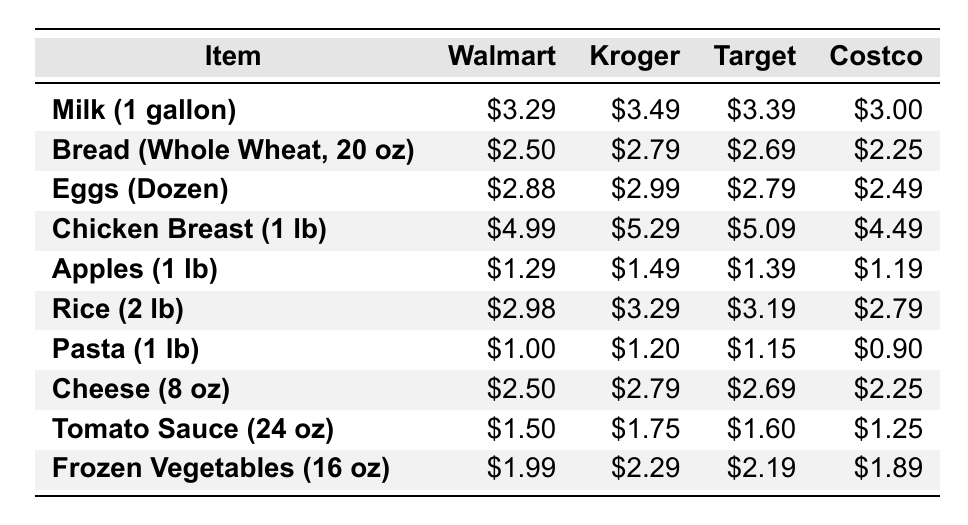What is the price of eggs at Costco? The table shows that in the row for "Eggs (Dozen)", the price at Costco is listed as $2.49.
Answer: $2.49 Which store offers the cheapest price for chicken breast? By examining the prices for "Chicken Breast (1 lb)", Costco charges $4.49, which is lower than Walmart's $4.99, Kroger's $5.29, and Target's $5.09.
Answer: Costco What is the difference in price between rice at Walmart and Costco? The price for "Rice (2 lb)" at Walmart is $2.98 and at Costco it is $2.79. The difference is calculated as $2.98 - $2.79 = $0.19.
Answer: $0.19 Which item is the most expensive at Walmart? Looking through the Walmart prices, "Chicken Breast (1 lb)" is $4.99, which is higher than all other items listed, making it the most expensive item at Walmart.
Answer: Chicken Breast How much more expensive is cheese at Kroger than at Costco? The price of "Cheese (8 oz)" at Kroger is $2.79, and at Costco, it is $2.25. The difference is $2.79 - $2.25 = $0.54.
Answer: $0.54 What is the average price of apples across all stores? The prices of apples at each store are: Walmart $1.29, Kroger $1.49, Target $1.39, and Costco $1.19. The total is $1.29 + $1.49 + $1.39 + $1.19 = $5.36, and there are 4 stores, so the average is $5.36 / 4 = $1.34.
Answer: $1.34 Is the price of milk at Target higher than at Walmart? According to the table, "Milk (1 gallon)" costs $3.39 at Target and $3.29 at Walmart. Since $3.39 is greater than $3.29, the statement is true.
Answer: Yes Which store has the highest price for frozen vegetables? The row for "Frozen Vegetables (16 oz)" shows Walmart at $1.99, Kroger at $2.29, Target at $2.19, and Costco at $1.89, with Kroger having the highest at $2.29.
Answer: Kroger How much would it cost to buy one of each item at Costco? Summing the prices for each item at Costco gives: $3.00 (milk) + $2.25 (bread) + $2.49 (eggs) + $4.49 (chicken) + $1.19 (apples) + $2.79 (rice) + $0.90 (pasta) + $2.25 (cheese) + $1.25 (sauce) + $1.89 (vegetables) = $22.06.
Answer: $22.06 Is the combined price of eggs and cheese cheaper at Walmart than at Target? Walmart's prices for eggs and cheese are $2.88 and $2.50 respectively, adding up to $5.38. At Target, the prices are $2.79 (eggs) and $2.69 (cheese), totaling $5.48. Since $5.38 < $5.48, Walmart is cheaper.
Answer: Yes 